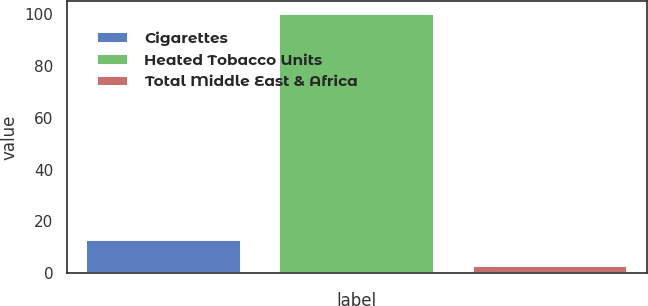Convert chart. <chart><loc_0><loc_0><loc_500><loc_500><bar_chart><fcel>Cigarettes<fcel>Heated Tobacco Units<fcel>Total Middle East & Africa<nl><fcel>12.7<fcel>100<fcel>3<nl></chart> 